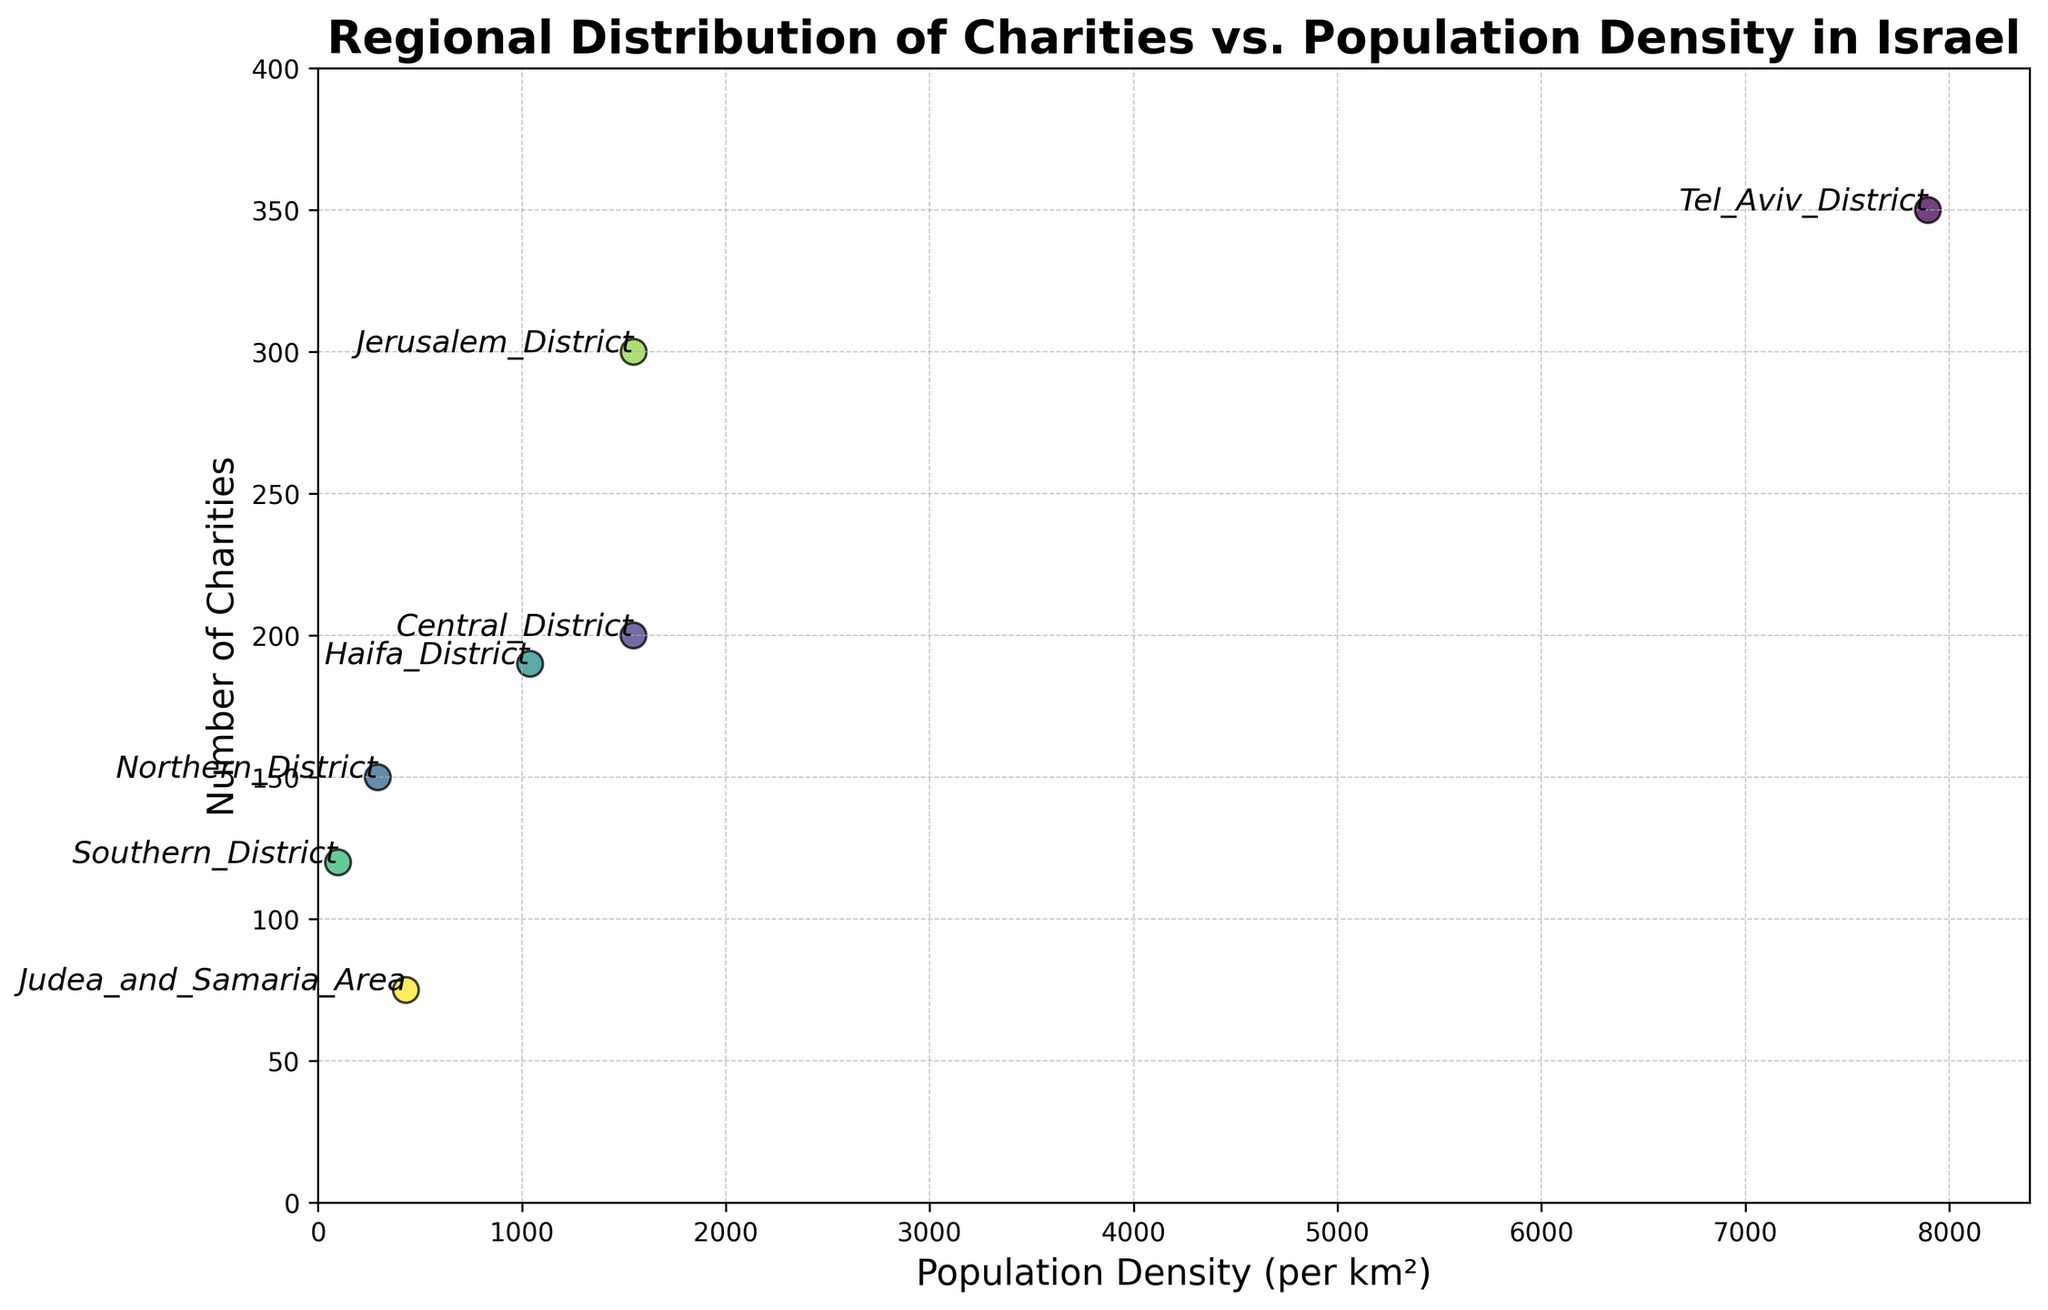What region has the highest population density? Tel Aviv District is located the furthest to the right on the X-axis, indicating its highest population density of 7896 per km².
Answer: Tel Aviv District How many regions have more than 200 charities? By counting the points above the 200 charities level on the Y-axis: Tel Aviv District (350), Jerusalem District (300), and Central District (200). Hence, there are 2 regions with more than 200 charities.
Answer: 2 Which region has the lowest number of charities, and what is its population density? Judea and Samaria Area has the lowest number of charities at 75. Referring to the X-axis for its population density, it is 431 per km².
Answer: Judea and Samaria Area, 431 What is the total number of charities in the Tel Aviv District and the Central District? Tel Aviv District has 350 charities, and Central District has 200. Adding them together, 350 + 200 = 550.
Answer: 550 Which regions have almost similar population densities, and what are they? By observing the X-axis, Central District (1547) and Jerusalem District (1548) have almost similar population densities of around 1547-1548 per km².
Answer: Central District and Jerusalem District What is the difference in the number of charities between the Haifa District and the Southern District? Haifa District has 190 charities, and Southern District has 120. The difference is 190 - 120 = 70.
Answer: 70 Which region lies closest to the origin (0, 0) in terms of the metric values? The Southern District, with the smallest population density (98 per km²) and a lower number of charities (120), lies closest to the origin.
Answer: Southern District Which region has the highest number of charities, and what is its population density? Tel Aviv District has the highest number of charities at 350. Referring to the X-axis, its population density is 7896 per km².
Answer: Tel Aviv District, 7896 How many regions have a population density below 1000 per km²? By examining the X-axis, Northern District (293), Southern District (98), and Judea and Samaria Area (431) have densities below 1000. Hence, 3 regions fall into this category.
Answer: 3 What is the average population density of regions with fewer than 150 charities? Regions with fewer than 150 charities are Southern District (120) and Judea and Samaria Area (75). Their densities are 98 and 431 respectively. Thus, (98 + 431) / 2 = 264.5.
Answer: 264.5 